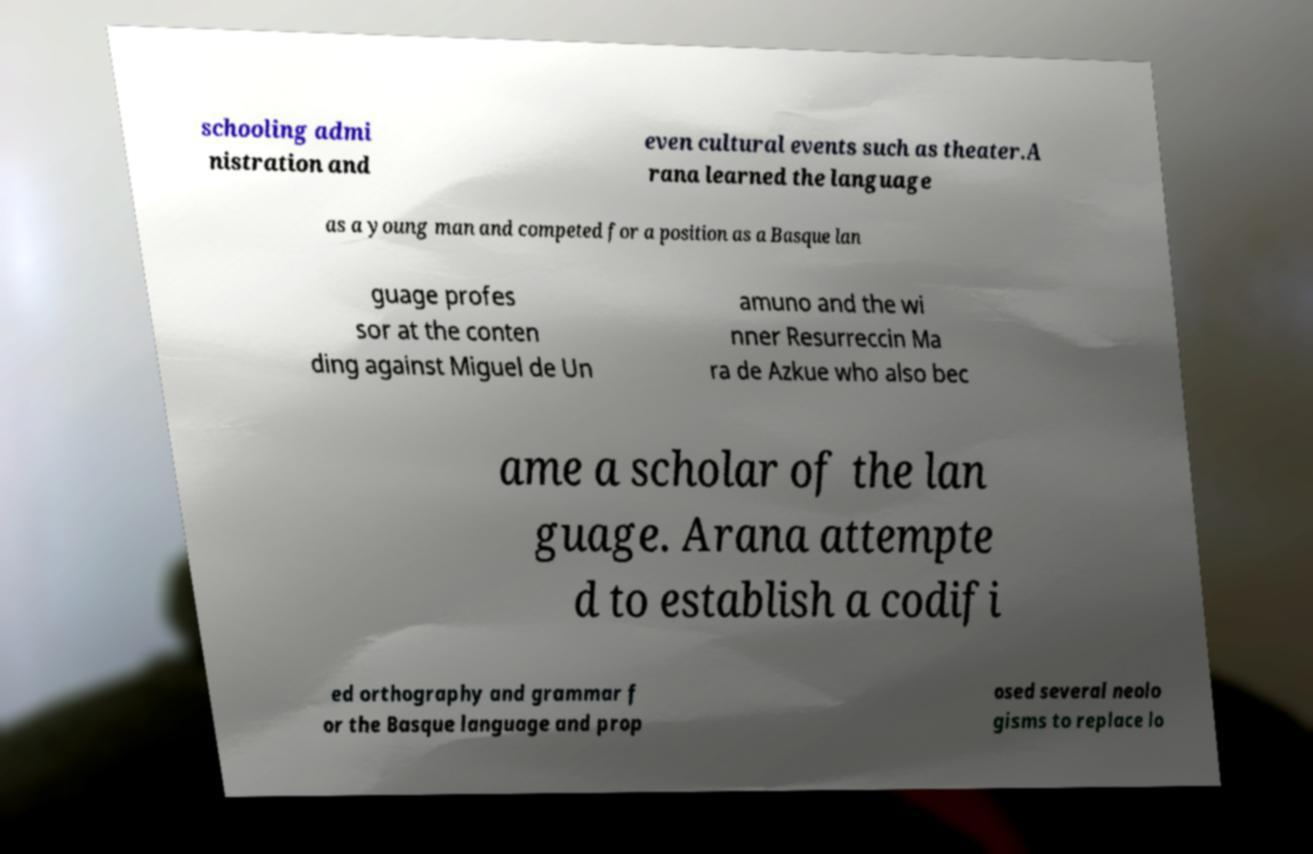I need the written content from this picture converted into text. Can you do that? schooling admi nistration and even cultural events such as theater.A rana learned the language as a young man and competed for a position as a Basque lan guage profes sor at the conten ding against Miguel de Un amuno and the wi nner Resurreccin Ma ra de Azkue who also bec ame a scholar of the lan guage. Arana attempte d to establish a codifi ed orthography and grammar f or the Basque language and prop osed several neolo gisms to replace lo 